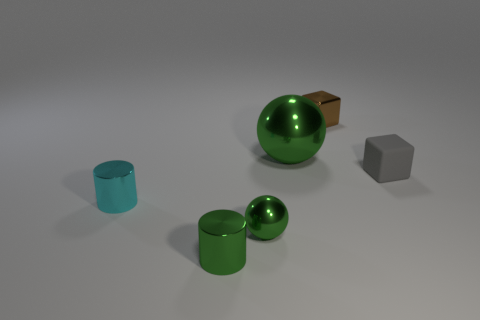Add 2 big green shiny things. How many objects exist? 8 Subtract all balls. How many objects are left? 4 Subtract all tiny blue objects. Subtract all gray objects. How many objects are left? 5 Add 6 big things. How many big things are left? 7 Add 4 tiny gray matte blocks. How many tiny gray matte blocks exist? 5 Subtract 0 blue spheres. How many objects are left? 6 